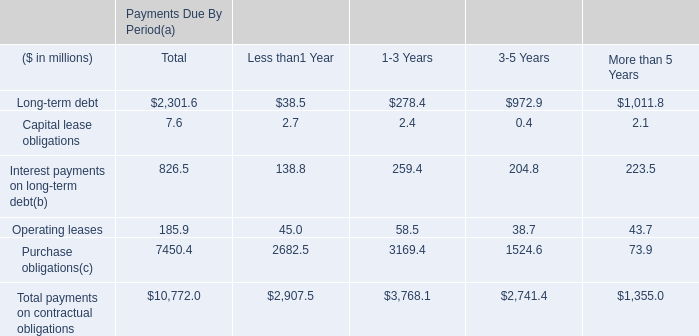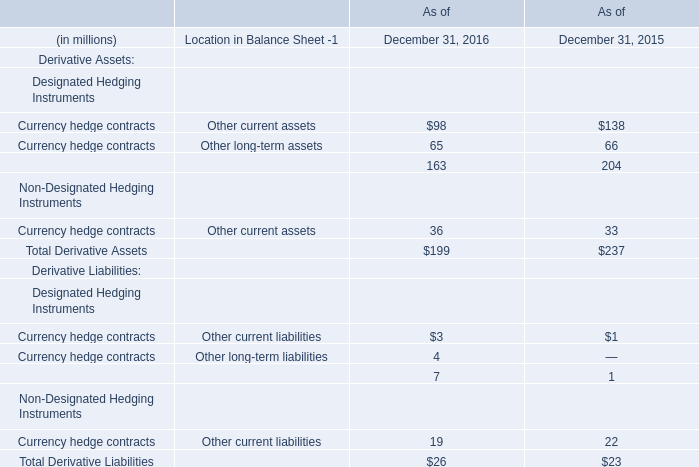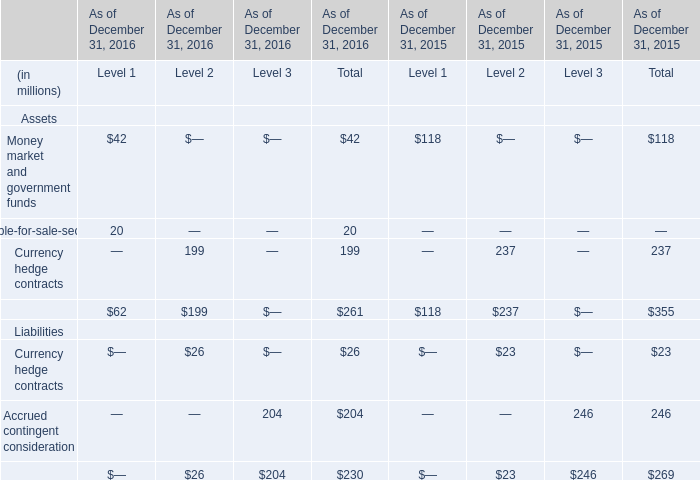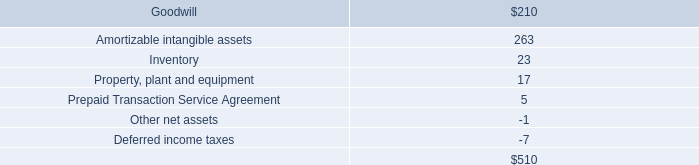What is the growing rate of Total Derivative Liabilities in the years with the least Total Derivative Assets? 
Computations: ((26 - 23) / 26)
Answer: 0.11538. 